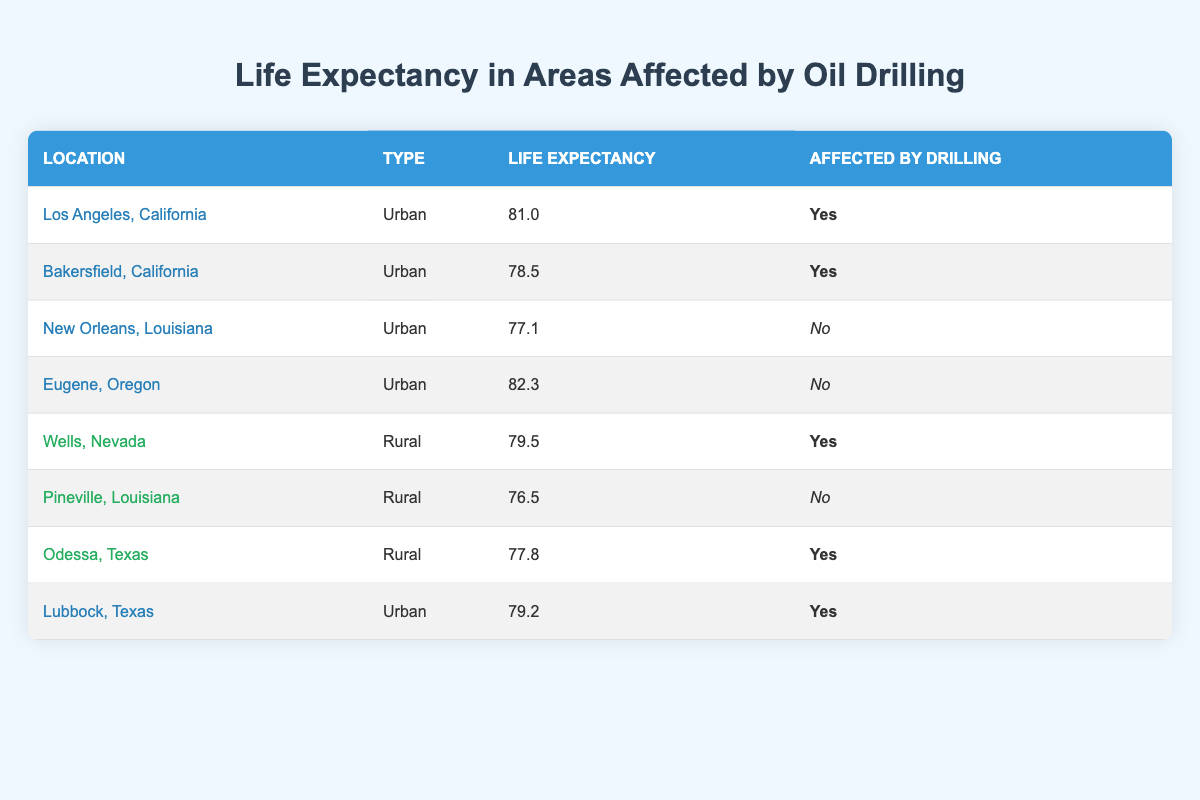What is the life expectancy in Los Angeles, California? The table shows a row for Los Angeles, California, where the life expectancy is listed directly as 81.0.
Answer: 81.0 Which urban area has the lowest life expectancy affected by drilling? The urban areas affected by drilling in the table are Los Angeles and Bakersfield. Comparing their life expectancies, 78.5 in Bakersfield is lower than 81.0 in Los Angeles.
Answer: Bakersfield, California What is the average life expectancy of rural areas not affected by drilling? The table shows only one rural area not affected by drilling, which is Pineville, Louisiana (76.5). Since there is only one area, the average is simply its life expectancy.
Answer: 76.5 Is Eugene, Oregon affected by oil drilling? In the table, Eugene, Oregon is listed as not affected by drilling, as indicated in the "Affected by Drilling" column.
Answer: No What is the difference in life expectancy between urban areas affected by drilling and those not affected? Urban areas affected by drilling are Los Angeles (81.0) and Bakersfield (78.5), averaging at (81.0 + 78.5) / 2 = 79.75. Areas not affected are New Orleans (77.1) and Eugene (82.3), averaging at (77.1 + 82.3) / 2 = 79.7. Therefore, the difference is 79.75 - 79.7 = 0.05.
Answer: 0.05 Which location has the highest life expectancy among urban areas? The table indicates that Eugene, Oregon has the highest life expectancy among the urban areas at 82.3.
Answer: Eugene, Oregon How many rural areas are affected by drilling? From the table, there are two rural locations listed as affected by drilling: Wells, Nevada and Odessa, Texas. Therefore, there are two affected rural areas.
Answer: 2 What is the total life expectancy of all the urban areas listed in the table? The life expectancies of urban areas in the table are 81.0 (Los Angeles) + 78.5 (Bakersfield) + 77.1 (New Orleans) + 82.3 (Eugene) + 79.2 (Lubbock). Summing these gives 81.0 + 78.5 + 77.1 + 82.3 + 79.2 = 398.1.
Answer: 398.1 